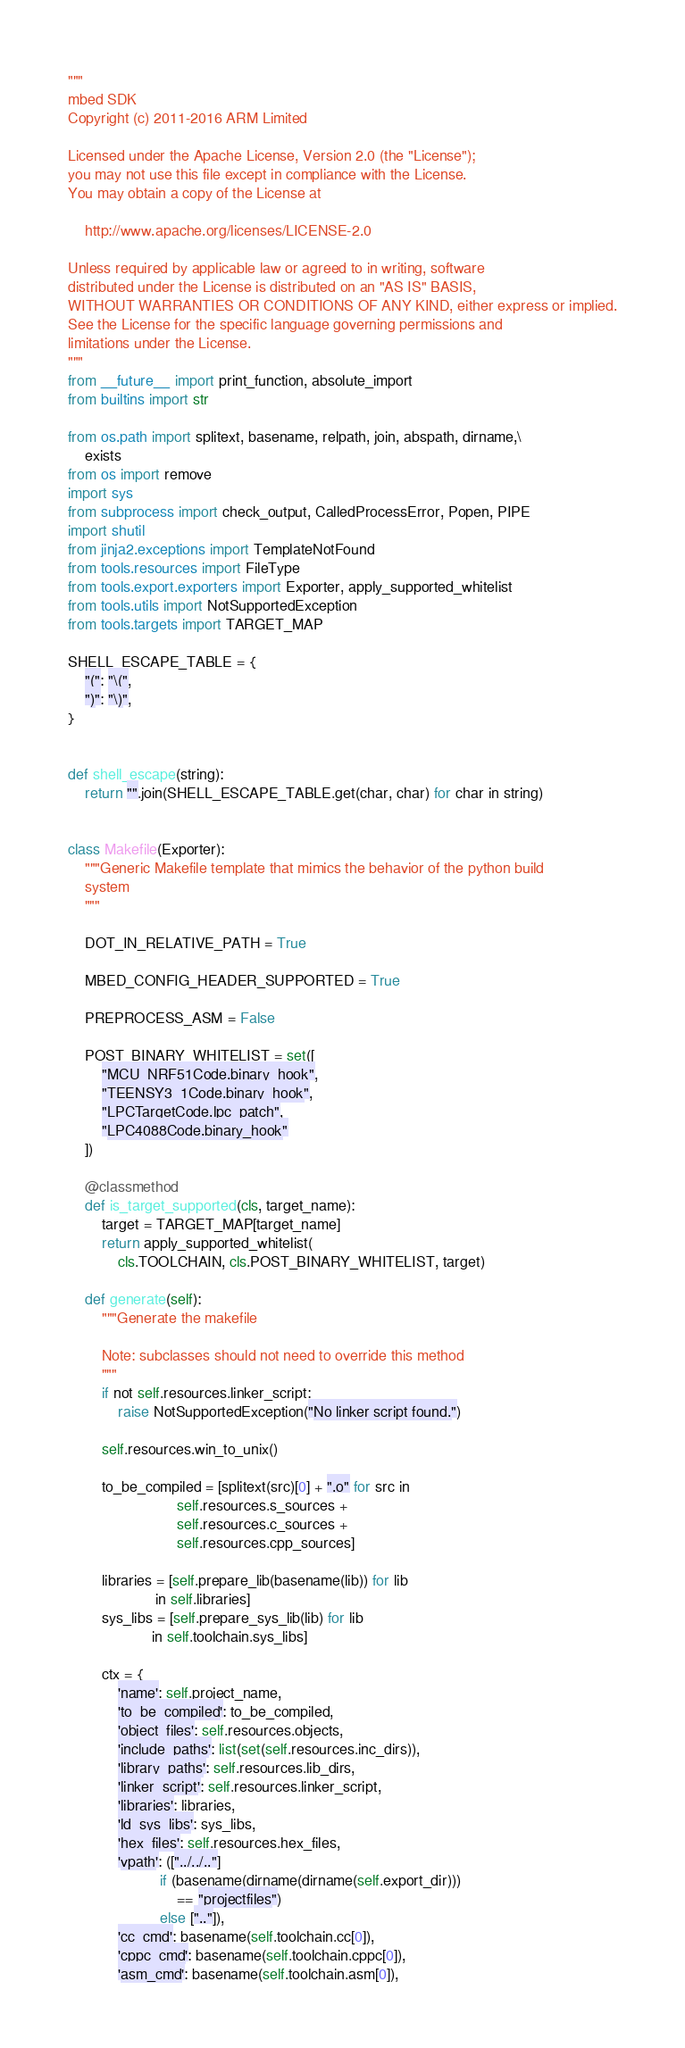<code> <loc_0><loc_0><loc_500><loc_500><_Python_>"""
mbed SDK
Copyright (c) 2011-2016 ARM Limited

Licensed under the Apache License, Version 2.0 (the "License");
you may not use this file except in compliance with the License.
You may obtain a copy of the License at

    http://www.apache.org/licenses/LICENSE-2.0

Unless required by applicable law or agreed to in writing, software
distributed under the License is distributed on an "AS IS" BASIS,
WITHOUT WARRANTIES OR CONDITIONS OF ANY KIND, either express or implied.
See the License for the specific language governing permissions and
limitations under the License.
"""
from __future__ import print_function, absolute_import
from builtins import str

from os.path import splitext, basename, relpath, join, abspath, dirname,\
    exists
from os import remove
import sys
from subprocess import check_output, CalledProcessError, Popen, PIPE
import shutil
from jinja2.exceptions import TemplateNotFound
from tools.resources import FileType
from tools.export.exporters import Exporter, apply_supported_whitelist
from tools.utils import NotSupportedException
from tools.targets import TARGET_MAP

SHELL_ESCAPE_TABLE = {
    "(": "\(",
    ")": "\)",
}


def shell_escape(string):
    return "".join(SHELL_ESCAPE_TABLE.get(char, char) for char in string)


class Makefile(Exporter):
    """Generic Makefile template that mimics the behavior of the python build
    system
    """

    DOT_IN_RELATIVE_PATH = True

    MBED_CONFIG_HEADER_SUPPORTED = True

    PREPROCESS_ASM = False

    POST_BINARY_WHITELIST = set([
        "MCU_NRF51Code.binary_hook",
        "TEENSY3_1Code.binary_hook",
        "LPCTargetCode.lpc_patch",
        "LPC4088Code.binary_hook"
    ])

    @classmethod
    def is_target_supported(cls, target_name):
        target = TARGET_MAP[target_name]
        return apply_supported_whitelist(
            cls.TOOLCHAIN, cls.POST_BINARY_WHITELIST, target)

    def generate(self):
        """Generate the makefile

        Note: subclasses should not need to override this method
        """
        if not self.resources.linker_script:
            raise NotSupportedException("No linker script found.")

        self.resources.win_to_unix()

        to_be_compiled = [splitext(src)[0] + ".o" for src in
                          self.resources.s_sources +
                          self.resources.c_sources +
                          self.resources.cpp_sources]

        libraries = [self.prepare_lib(basename(lib)) for lib
                     in self.libraries]
        sys_libs = [self.prepare_sys_lib(lib) for lib
                    in self.toolchain.sys_libs]

        ctx = {
            'name': self.project_name,
            'to_be_compiled': to_be_compiled,
            'object_files': self.resources.objects,
            'include_paths': list(set(self.resources.inc_dirs)),
            'library_paths': self.resources.lib_dirs,
            'linker_script': self.resources.linker_script,
            'libraries': libraries,
            'ld_sys_libs': sys_libs,
            'hex_files': self.resources.hex_files,
            'vpath': (["../../.."]
                      if (basename(dirname(dirname(self.export_dir)))
                          == "projectfiles")
                      else [".."]),
            'cc_cmd': basename(self.toolchain.cc[0]),
            'cppc_cmd': basename(self.toolchain.cppc[0]),
            'asm_cmd': basename(self.toolchain.asm[0]),</code> 